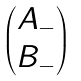<formula> <loc_0><loc_0><loc_500><loc_500>\begin{pmatrix} A _ { - } \\ B _ { - } \end{pmatrix}</formula> 